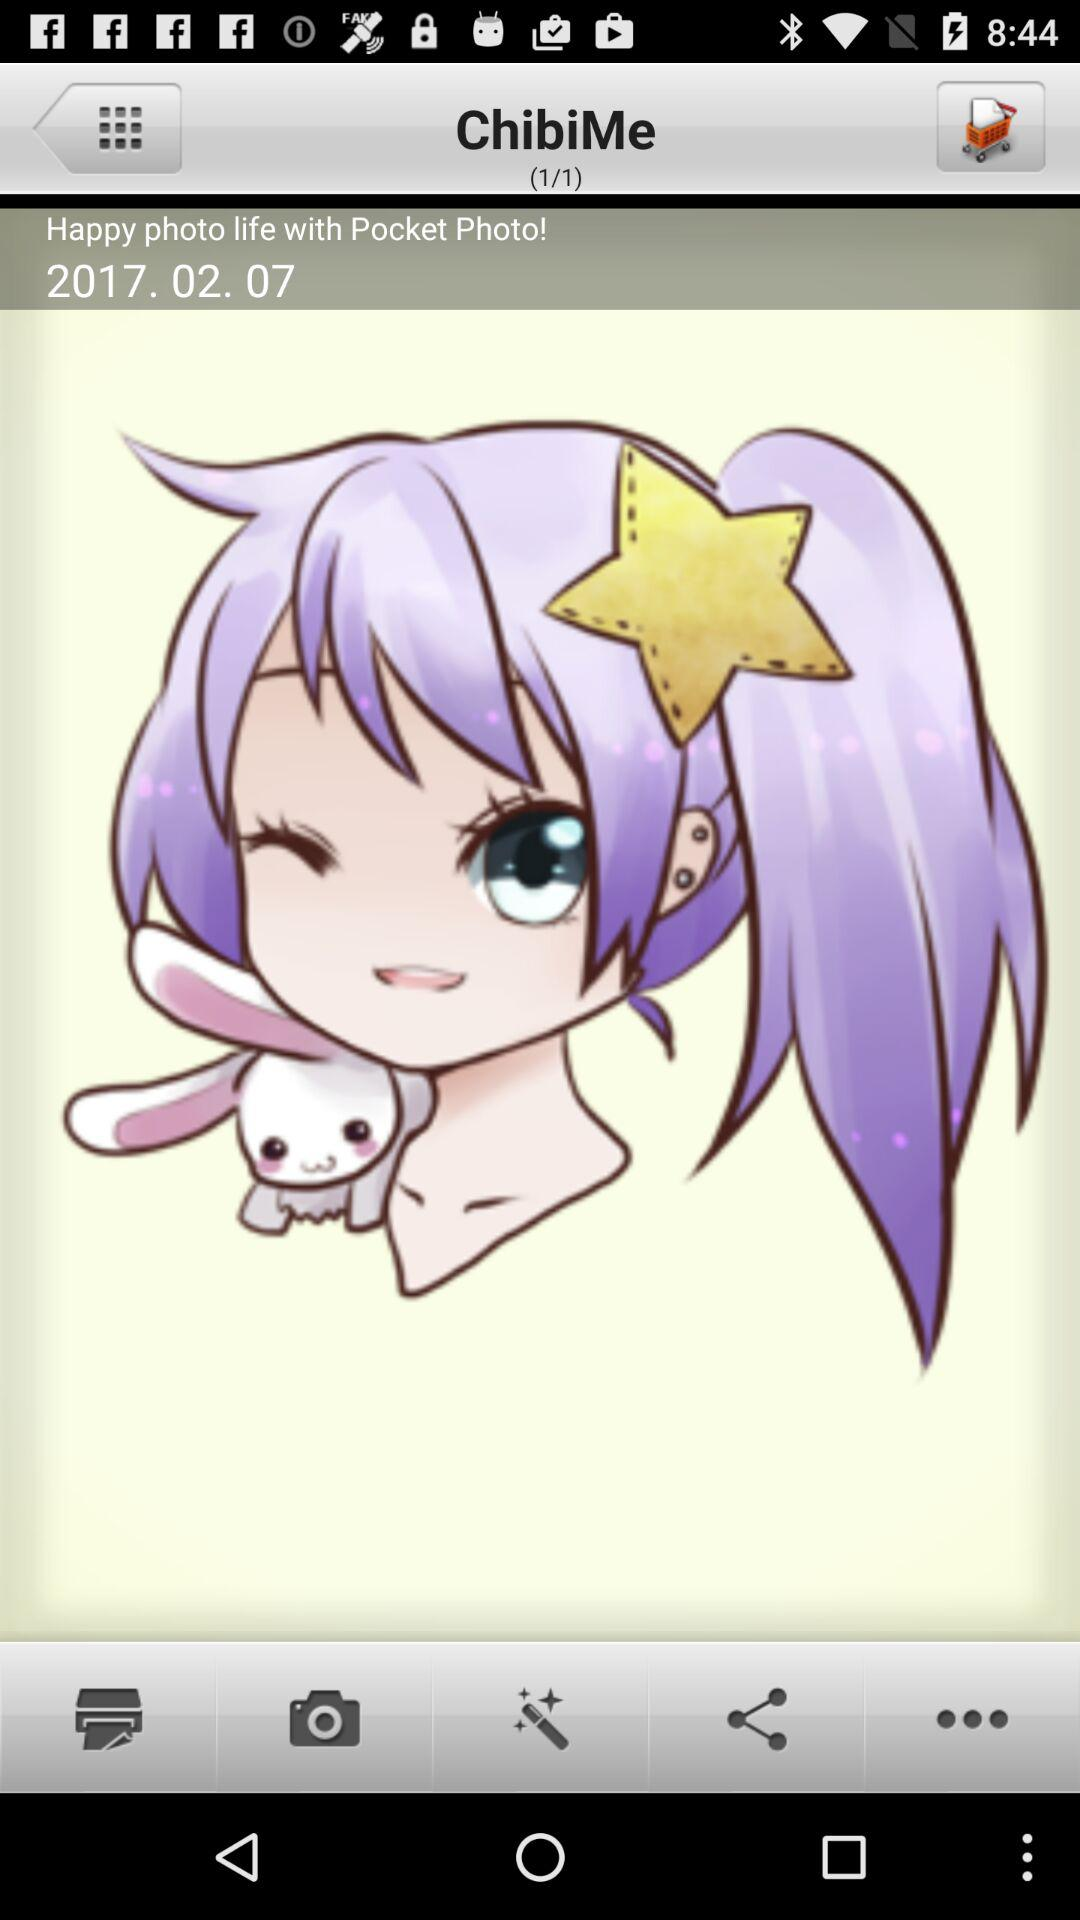Which applications are available for sharing?
When the provided information is insufficient, respond with <no answer>. <no answer> 